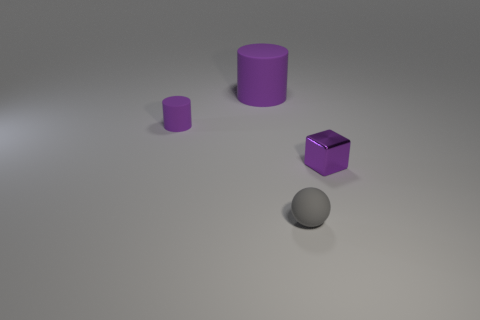How many other things are there of the same shape as the tiny purple matte object?
Ensure brevity in your answer.  1. There is a thing that is on the right side of the gray ball; what shape is it?
Make the answer very short. Cube. What color is the small shiny object?
Ensure brevity in your answer.  Purple. What number of other things are the same size as the gray sphere?
Provide a succinct answer. 2. What is the material of the tiny thing in front of the small object that is on the right side of the tiny gray ball?
Your response must be concise. Rubber. Is the size of the purple metal thing the same as the purple matte cylinder that is to the right of the tiny matte cylinder?
Your answer should be compact. No. Is there a tiny block that has the same color as the large rubber thing?
Provide a short and direct response. Yes. What number of small objects are either rubber objects or cyan blocks?
Provide a succinct answer. 2. How many big purple shiny balls are there?
Offer a very short reply. 0. There is a tiny purple thing that is left of the rubber ball; what material is it?
Make the answer very short. Rubber. 